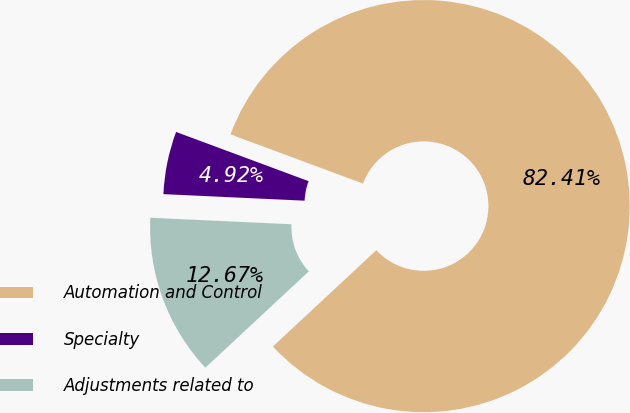Convert chart to OTSL. <chart><loc_0><loc_0><loc_500><loc_500><pie_chart><fcel>Automation and Control<fcel>Specialty<fcel>Adjustments related to<nl><fcel>82.4%<fcel>4.92%<fcel>12.67%<nl></chart> 